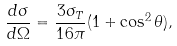<formula> <loc_0><loc_0><loc_500><loc_500>\frac { d \sigma } { d \Omega } = \frac { 3 \sigma _ { T } } { 1 6 \pi } ( 1 + \cos ^ { 2 } \theta ) ,</formula> 